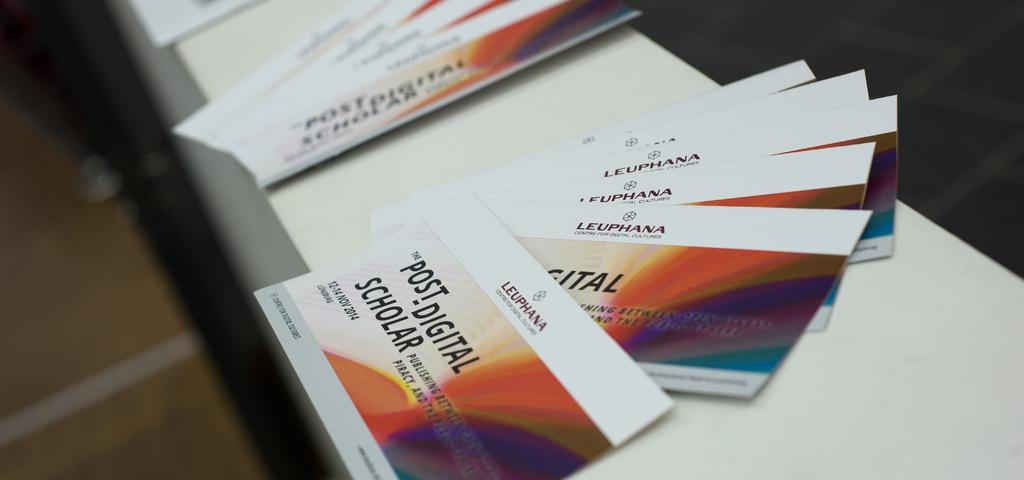<image>
Give a short and clear explanation of the subsequent image. Purple orange blue yellow Post Digital Scholar laying on a surface. 